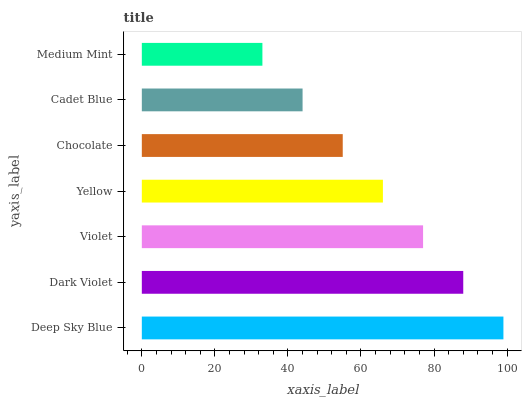Is Medium Mint the minimum?
Answer yes or no. Yes. Is Deep Sky Blue the maximum?
Answer yes or no. Yes. Is Dark Violet the minimum?
Answer yes or no. No. Is Dark Violet the maximum?
Answer yes or no. No. Is Deep Sky Blue greater than Dark Violet?
Answer yes or no. Yes. Is Dark Violet less than Deep Sky Blue?
Answer yes or no. Yes. Is Dark Violet greater than Deep Sky Blue?
Answer yes or no. No. Is Deep Sky Blue less than Dark Violet?
Answer yes or no. No. Is Yellow the high median?
Answer yes or no. Yes. Is Yellow the low median?
Answer yes or no. Yes. Is Cadet Blue the high median?
Answer yes or no. No. Is Chocolate the low median?
Answer yes or no. No. 